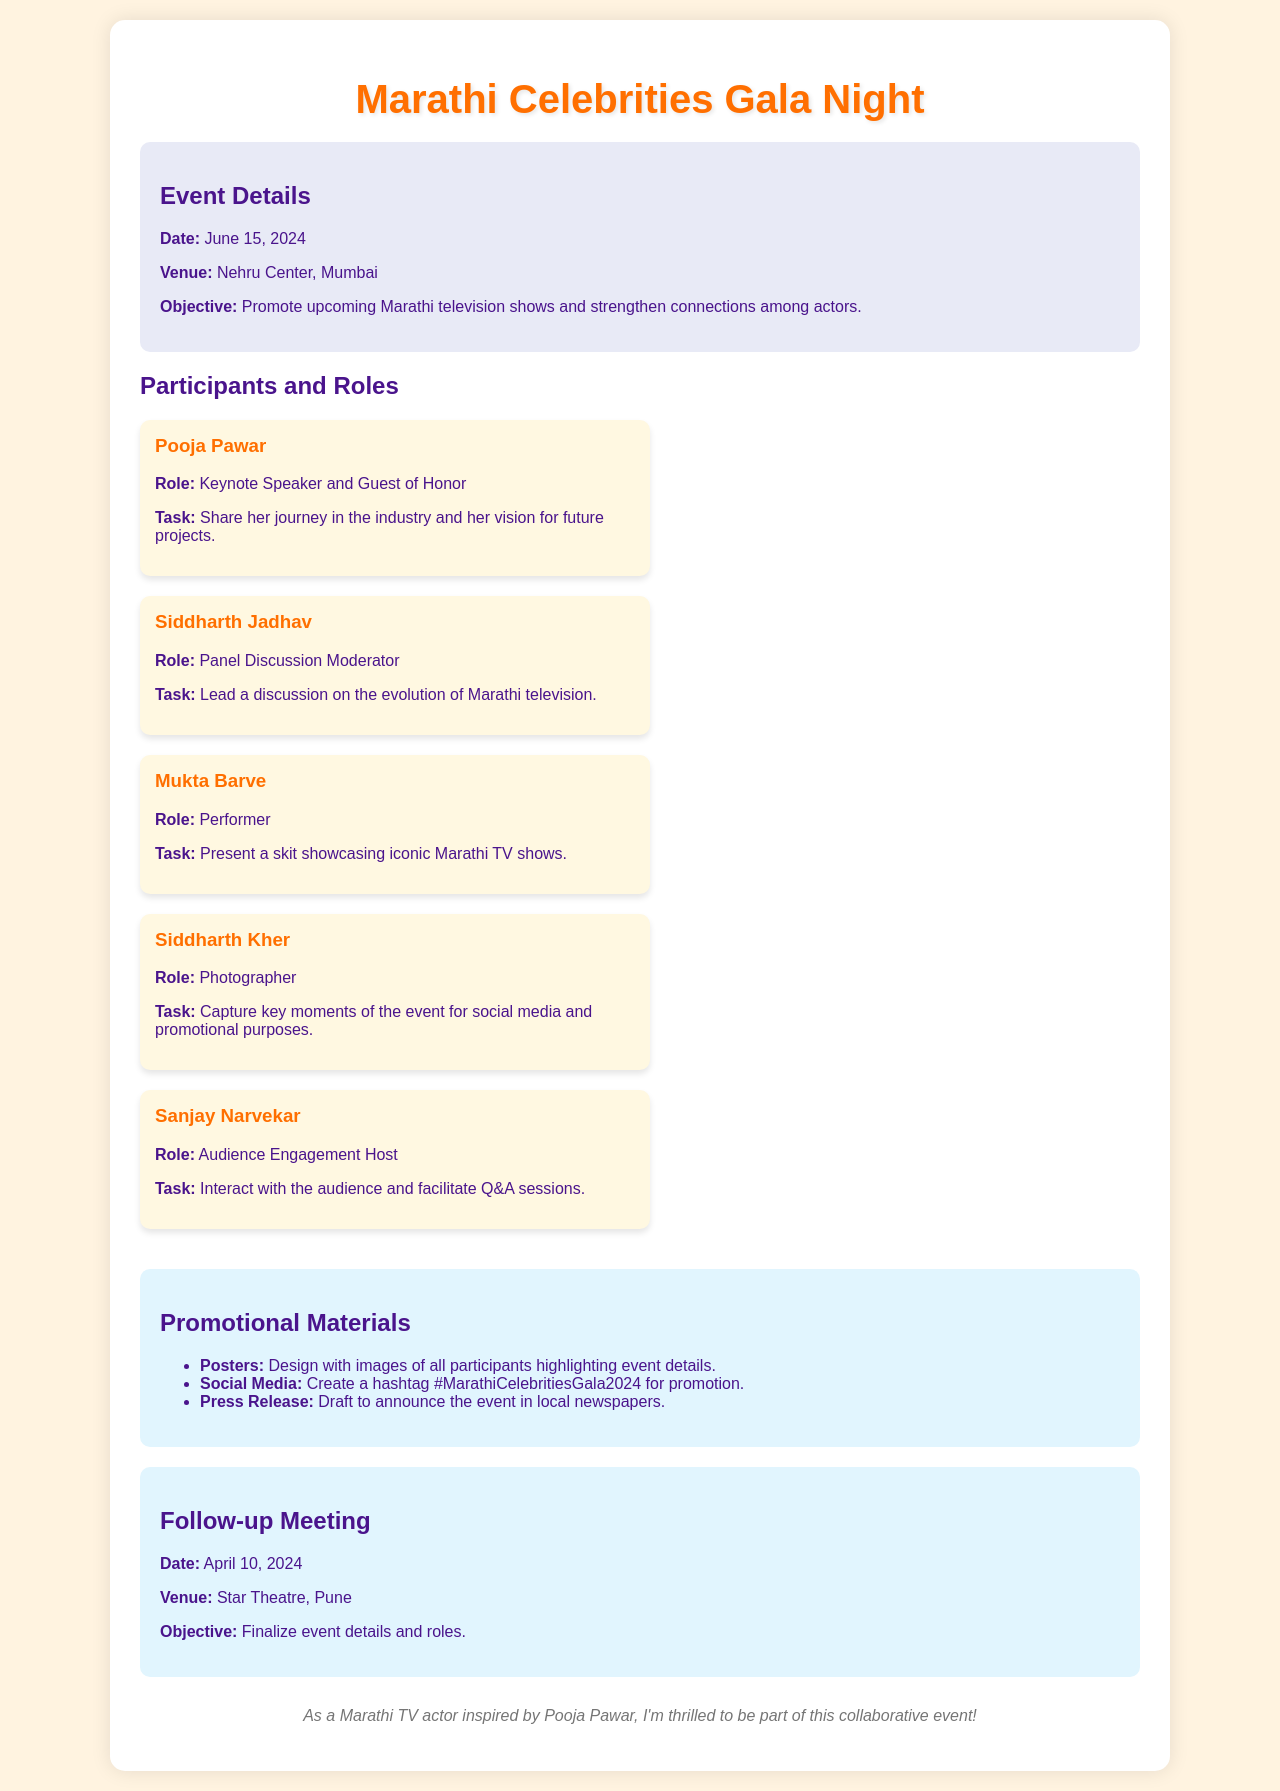What is the date of the event? The date of the event is clearly mentioned in the document as June 15, 2024.
Answer: June 15, 2024 Where is the event taking place? The venue for the event is specified in the document.
Answer: Nehru Center, Mumbai Who is the keynote speaker? The document identifies Pooja Pawar as the keynote speaker and guest of honor.
Answer: Pooja Pawar What is Siddharth Jadhav's role? The document outlines Siddharth Jadhav's role as the panel discussion moderator.
Answer: Panel Discussion Moderator What is the objective of the follow-up meeting? The document explains that the objective of the follow-up meeting is to finalize event details and roles.
Answer: Finalize event details and roles How many participants are listed in the document? The document lists five participants involved in the event.
Answer: Five What promotional material is suggested for the event? The document includes several promotional materials, one of them being posters designed with participant images.
Answer: Posters What task is assigned to Siddharth Kher? The document states that Siddharth Kher's task is to capture key moments of the event.
Answer: Capture key moments What date is the follow-up meeting scheduled for? The document specifically states that the follow-up meeting is on April 10, 2024.
Answer: April 10, 2024 